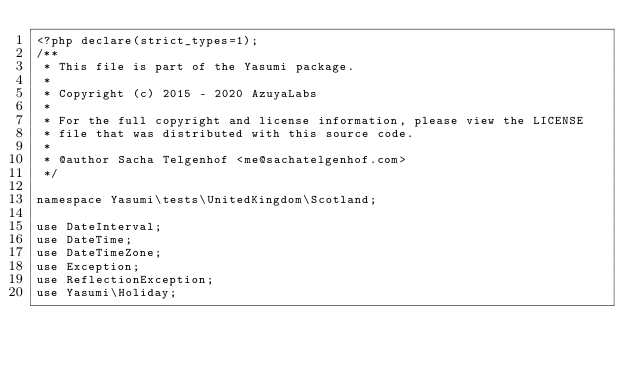<code> <loc_0><loc_0><loc_500><loc_500><_PHP_><?php declare(strict_types=1);
/**
 * This file is part of the Yasumi package.
 *
 * Copyright (c) 2015 - 2020 AzuyaLabs
 *
 * For the full copyright and license information, please view the LICENSE
 * file that was distributed with this source code.
 *
 * @author Sacha Telgenhof <me@sachatelgenhof.com>
 */

namespace Yasumi\tests\UnitedKingdom\Scotland;

use DateInterval;
use DateTime;
use DateTimeZone;
use Exception;
use ReflectionException;
use Yasumi\Holiday;</code> 